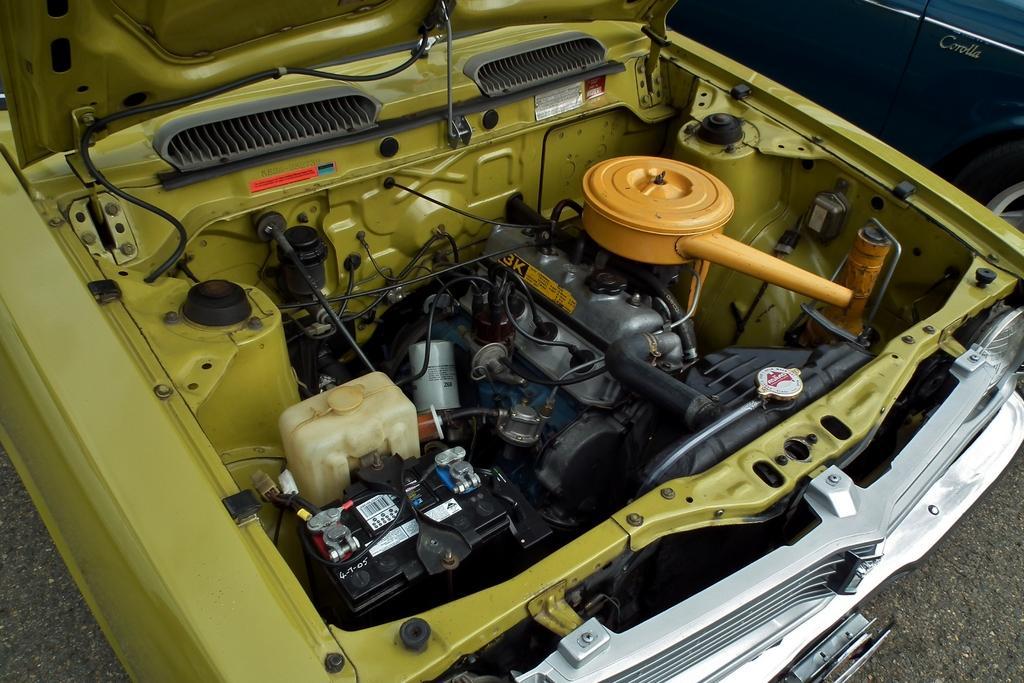Please provide a concise description of this image. In this picture, we can see a few cars, and we can see some car parts like engine, and we can the ground. 